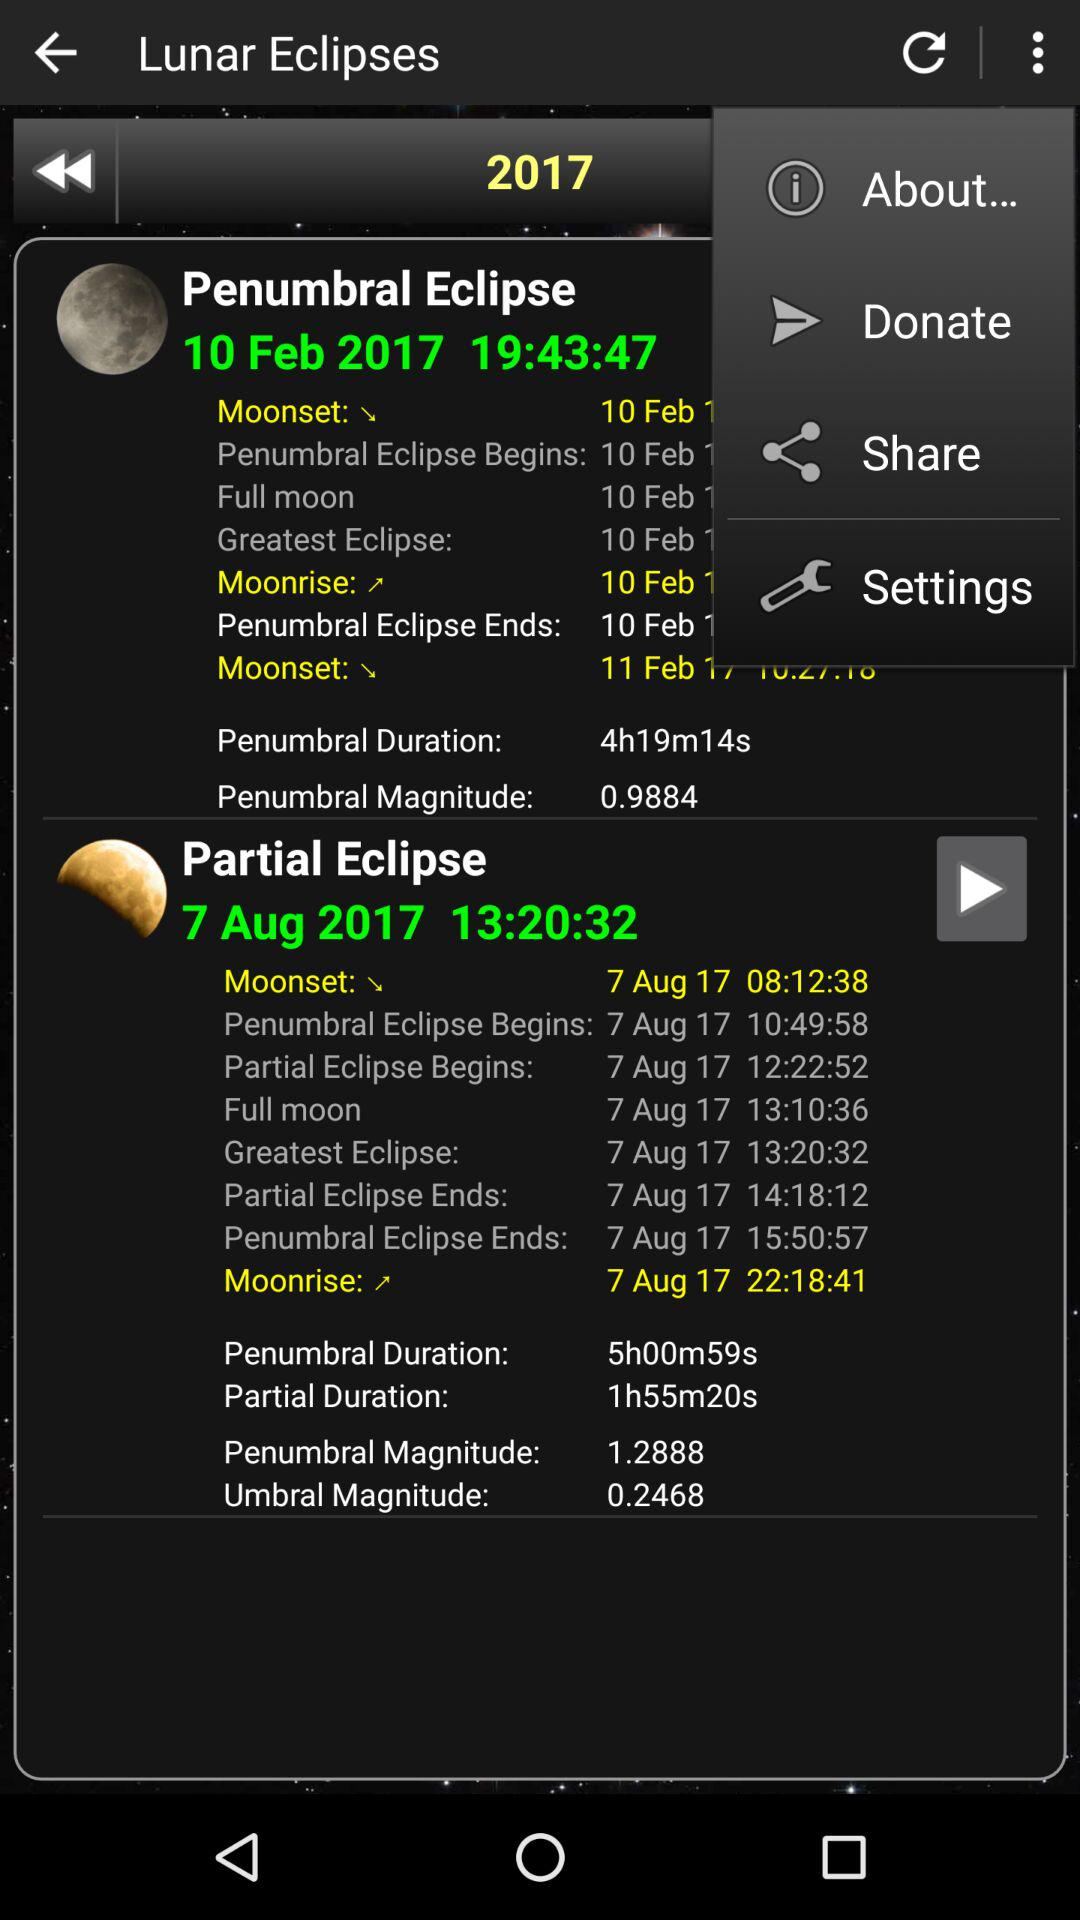What is the penumbral magnitude on February 10, 2017?
Answer the question using a single word or phrase. The penumbral magnitude is 0.9884 